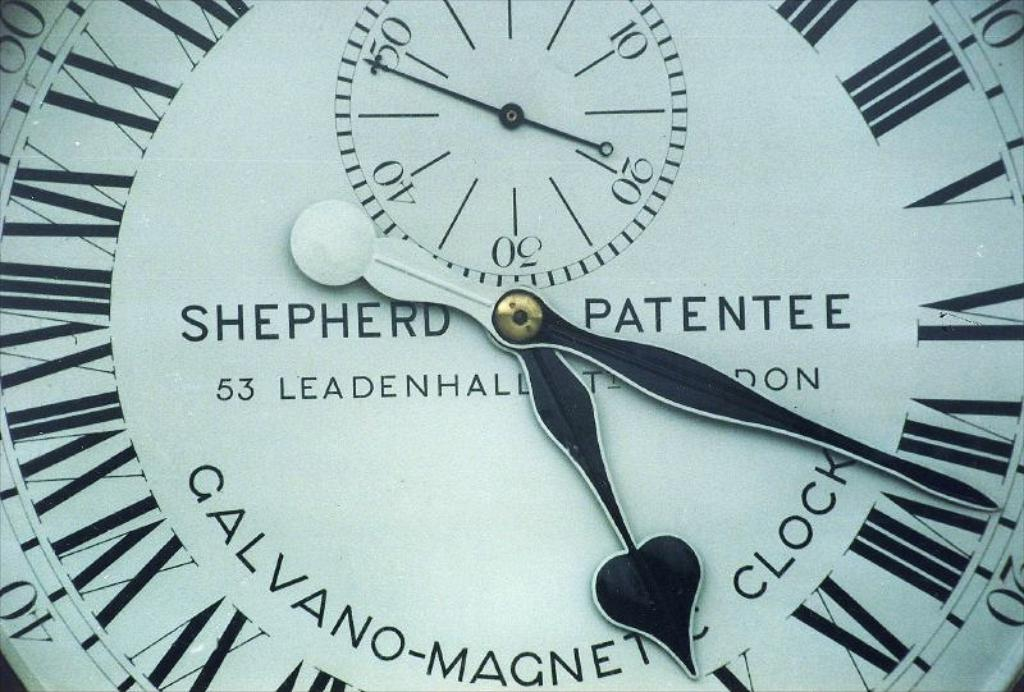What is the historical importance of Shepherd clocks, particularly the model shown? Shepherd clocks, such as the one depicted which is famously installed at the Royal Observatory in Greenwich, played a crucial role in measuring astronomical time accurately, aiding in navigation and timekeeping during the 19th century. Can you describe any specific design features visible in this clock face that reflect its historical context? The Roman numerals, ornate hands, and inner sub-dial on the clock face reflect the period's aesthetic preferences and technical advancements in clock design, emphasizing precision and elegance. 